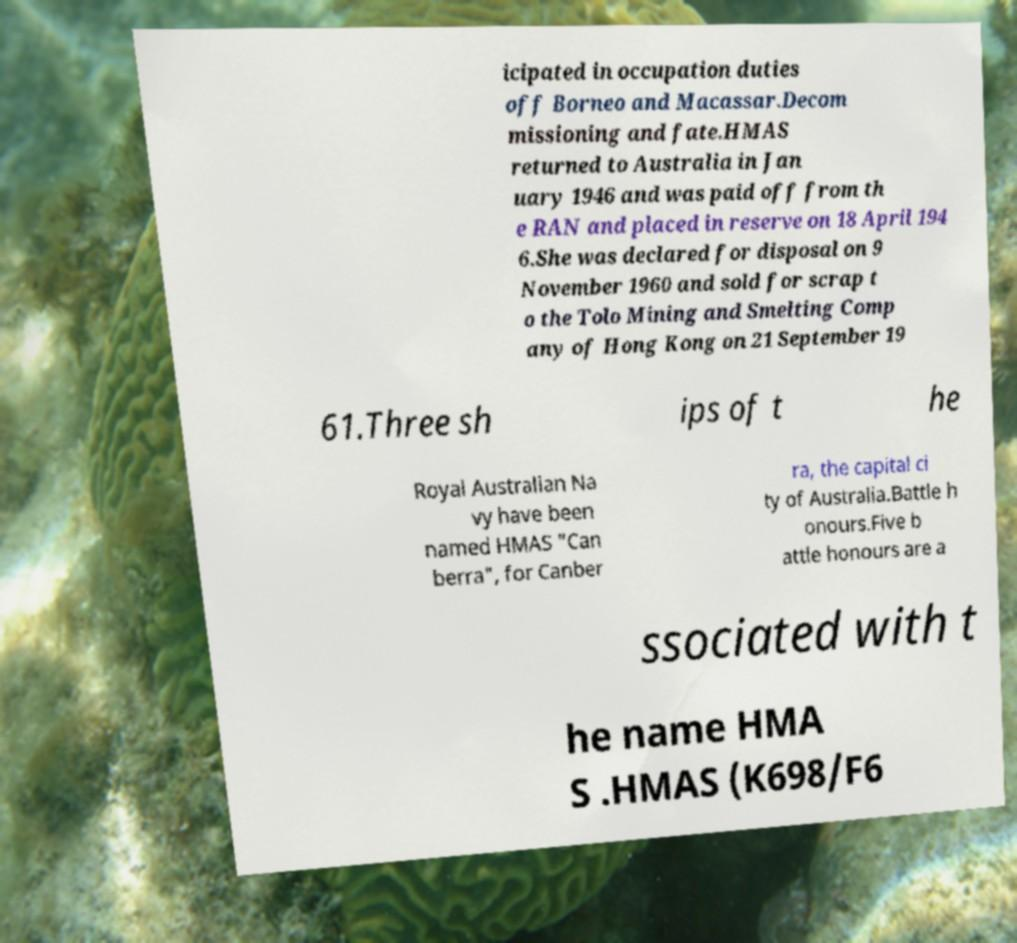For documentation purposes, I need the text within this image transcribed. Could you provide that? icipated in occupation duties off Borneo and Macassar.Decom missioning and fate.HMAS returned to Australia in Jan uary 1946 and was paid off from th e RAN and placed in reserve on 18 April 194 6.She was declared for disposal on 9 November 1960 and sold for scrap t o the Tolo Mining and Smelting Comp any of Hong Kong on 21 September 19 61.Three sh ips of t he Royal Australian Na vy have been named HMAS "Can berra", for Canber ra, the capital ci ty of Australia.Battle h onours.Five b attle honours are a ssociated with t he name HMA S .HMAS (K698/F6 